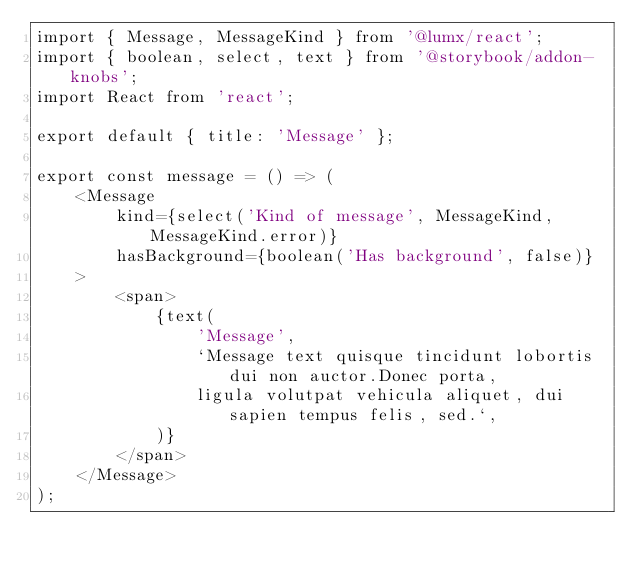Convert code to text. <code><loc_0><loc_0><loc_500><loc_500><_TypeScript_>import { Message, MessageKind } from '@lumx/react';
import { boolean, select, text } from '@storybook/addon-knobs';
import React from 'react';

export default { title: 'Message' };

export const message = () => (
    <Message
        kind={select('Kind of message', MessageKind, MessageKind.error)}
        hasBackground={boolean('Has background', false)}
    >
        <span>
            {text(
                'Message',
                `Message text quisque tincidunt lobortis dui non auctor.Donec porta,
                ligula volutpat vehicula aliquet, dui sapien tempus felis, sed.`,
            )}
        </span>
    </Message>
);
</code> 